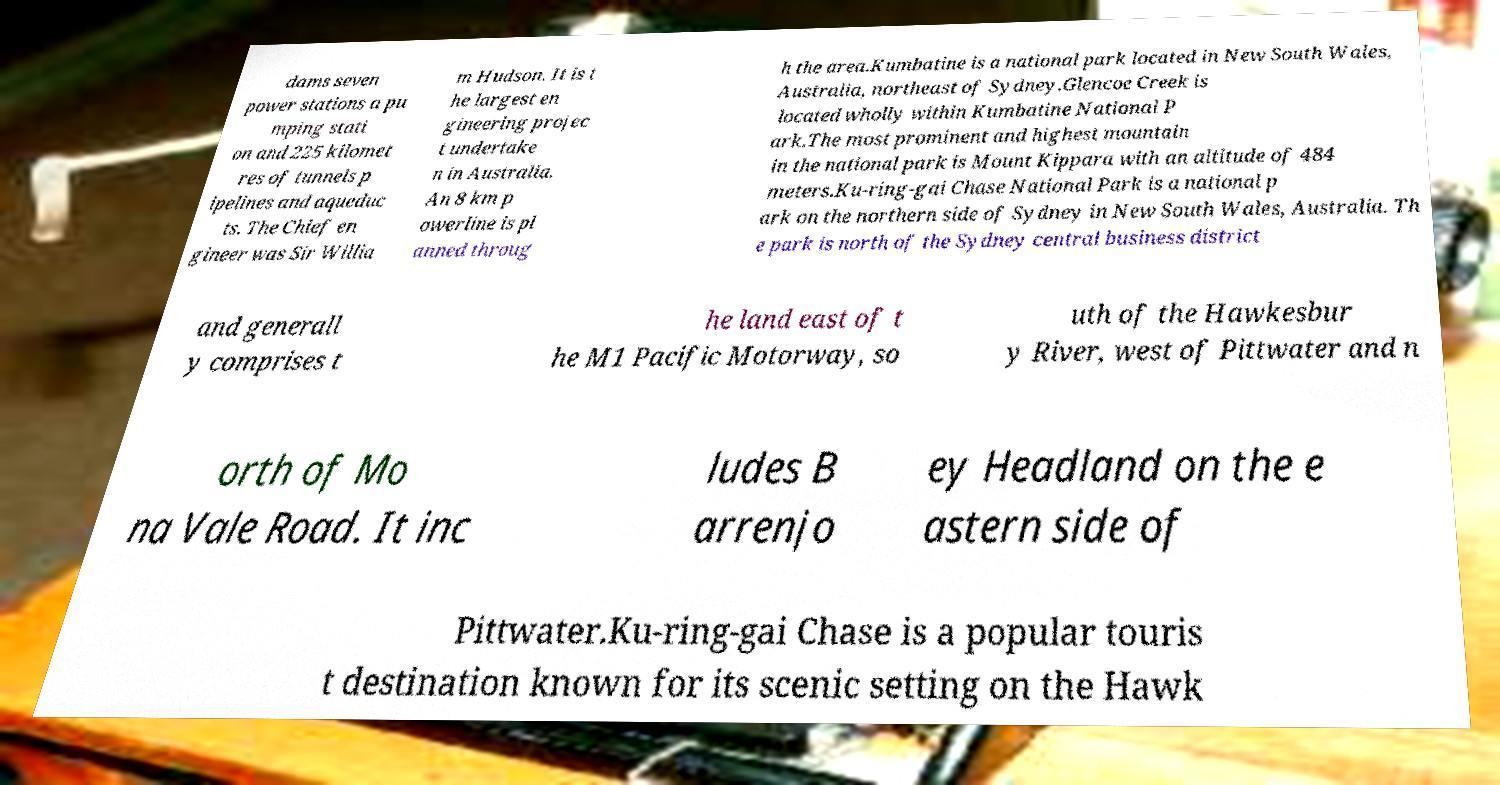Can you read and provide the text displayed in the image?This photo seems to have some interesting text. Can you extract and type it out for me? dams seven power stations a pu mping stati on and 225 kilomet res of tunnels p ipelines and aqueduc ts. The Chief en gineer was Sir Willia m Hudson. It is t he largest en gineering projec t undertake n in Australia. An 8 km p owerline is pl anned throug h the area.Kumbatine is a national park located in New South Wales, Australia, northeast of Sydney.Glencoe Creek is located wholly within Kumbatine National P ark.The most prominent and highest mountain in the national park is Mount Kippara with an altitude of 484 meters.Ku-ring-gai Chase National Park is a national p ark on the northern side of Sydney in New South Wales, Australia. Th e park is north of the Sydney central business district and generall y comprises t he land east of t he M1 Pacific Motorway, so uth of the Hawkesbur y River, west of Pittwater and n orth of Mo na Vale Road. It inc ludes B arrenjo ey Headland on the e astern side of Pittwater.Ku-ring-gai Chase is a popular touris t destination known for its scenic setting on the Hawk 